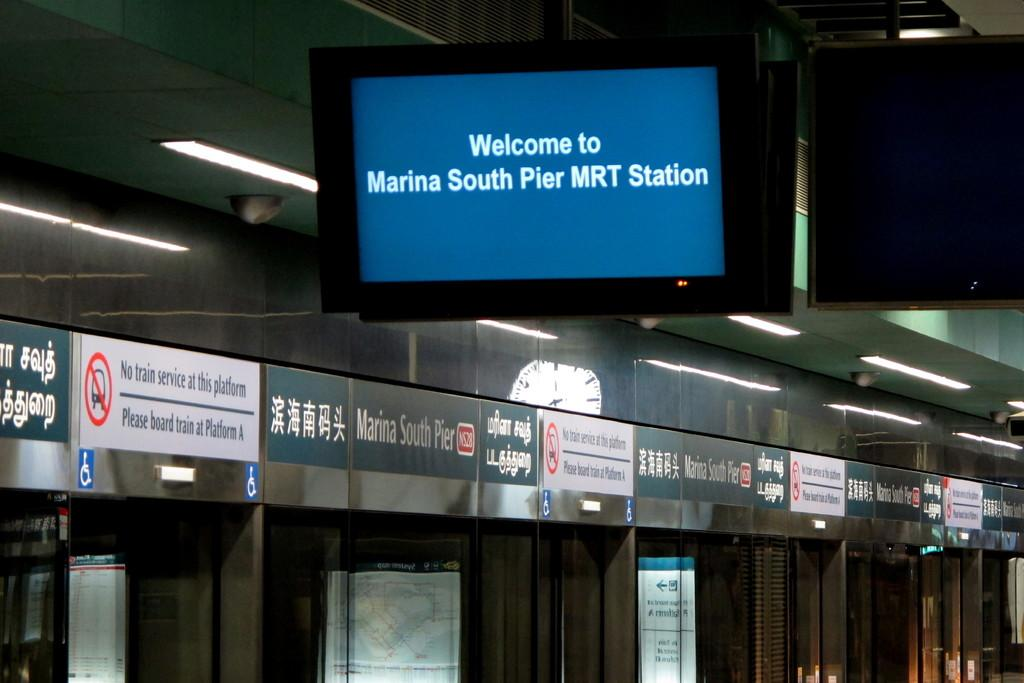Provide a one-sentence caption for the provided image. A train station has a monitor hanging from the ceiling that says Welcome to Marina South Pier MRT Station. 